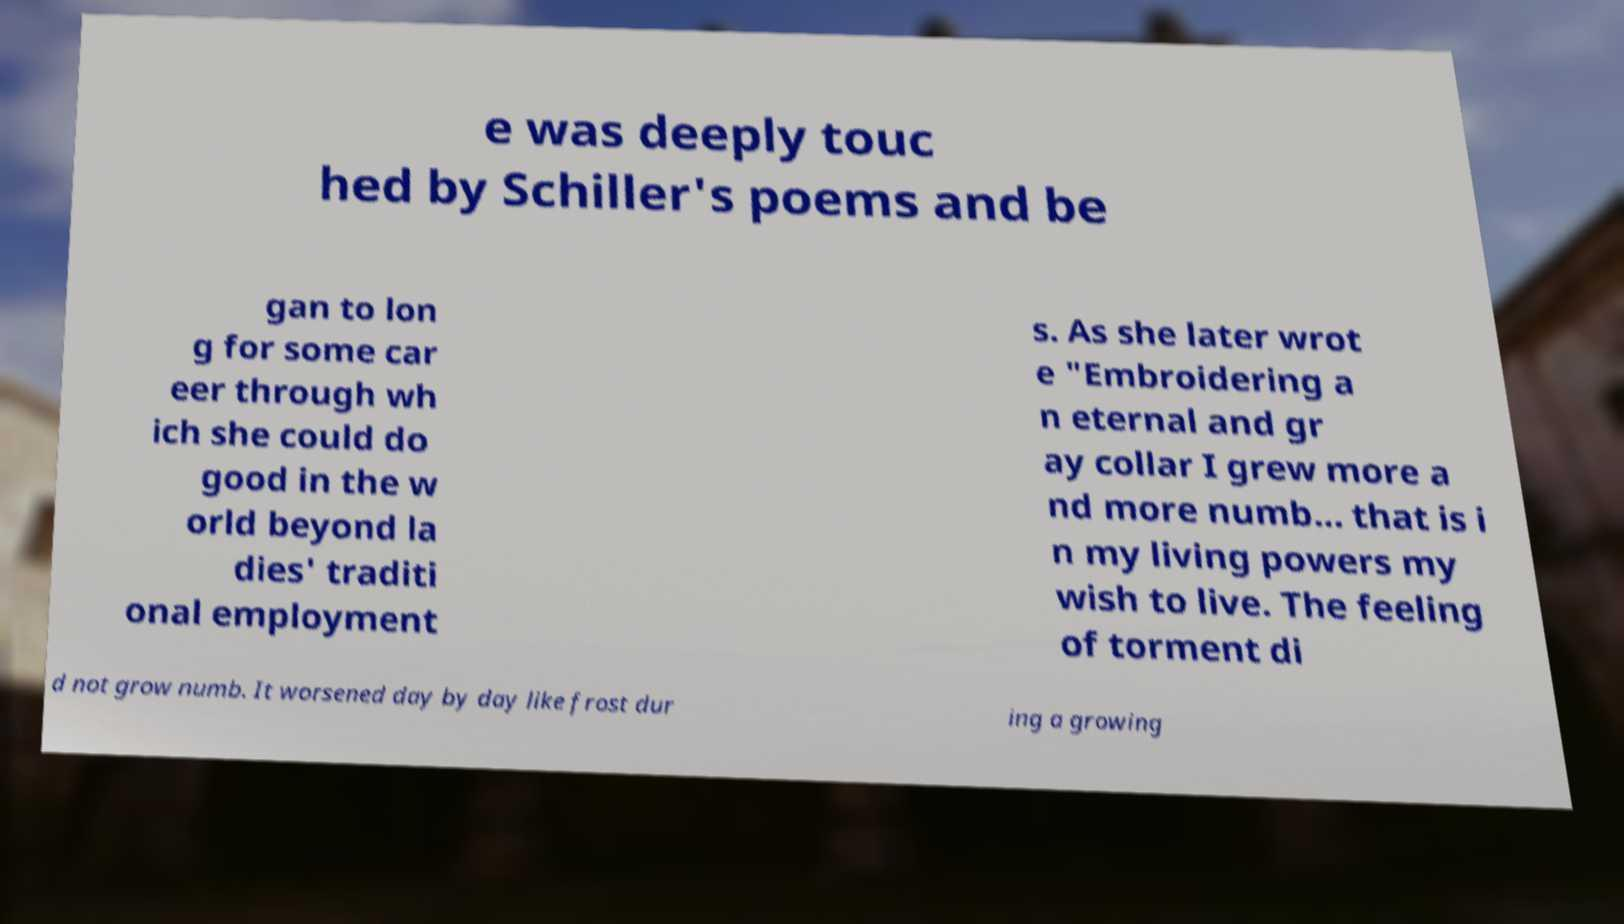Could you extract and type out the text from this image? e was deeply touc hed by Schiller's poems and be gan to lon g for some car eer through wh ich she could do good in the w orld beyond la dies' traditi onal employment s. As she later wrot e "Embroidering a n eternal and gr ay collar I grew more a nd more numb... that is i n my living powers my wish to live. The feeling of torment di d not grow numb. It worsened day by day like frost dur ing a growing 